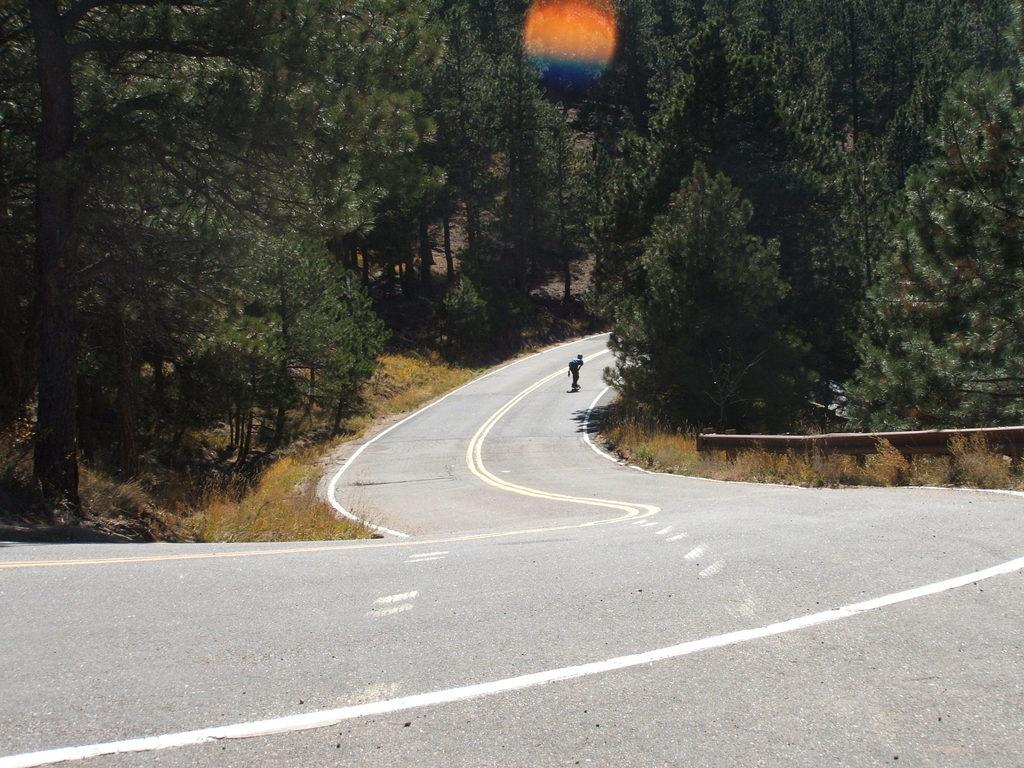What is the main subject of the image? The main subject of the image is a view of a road. What can be seen on both sides of the road? There are trees on both sides of the road. Is there any activity happening on the road in the image? Yes, in the background, there is a boy doing skating on the road. What type of lunch is the boy eating while skating in the image? There is no mention of lunch in the image. 